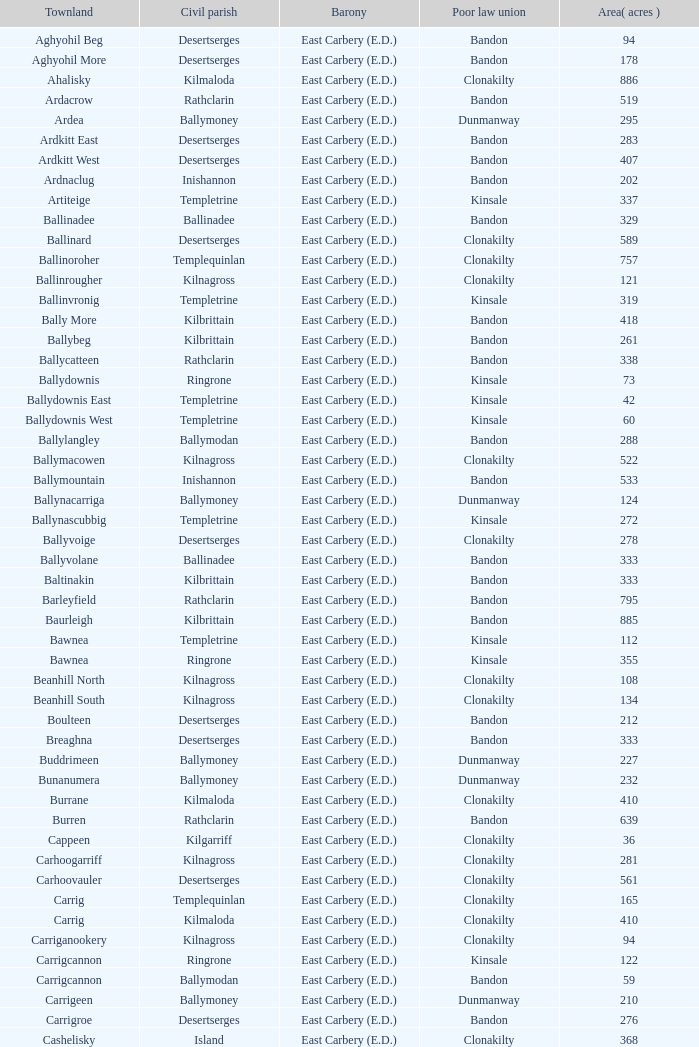Would you be able to parse every entry in this table? {'header': ['Townland', 'Civil parish', 'Barony', 'Poor law union', 'Area( acres )'], 'rows': [['Aghyohil Beg', 'Desertserges', 'East Carbery (E.D.)', 'Bandon', '94'], ['Aghyohil More', 'Desertserges', 'East Carbery (E.D.)', 'Bandon', '178'], ['Ahalisky', 'Kilmaloda', 'East Carbery (E.D.)', 'Clonakilty', '886'], ['Ardacrow', 'Rathclarin', 'East Carbery (E.D.)', 'Bandon', '519'], ['Ardea', 'Ballymoney', 'East Carbery (E.D.)', 'Dunmanway', '295'], ['Ardkitt East', 'Desertserges', 'East Carbery (E.D.)', 'Bandon', '283'], ['Ardkitt West', 'Desertserges', 'East Carbery (E.D.)', 'Bandon', '407'], ['Ardnaclug', 'Inishannon', 'East Carbery (E.D.)', 'Bandon', '202'], ['Artiteige', 'Templetrine', 'East Carbery (E.D.)', 'Kinsale', '337'], ['Ballinadee', 'Ballinadee', 'East Carbery (E.D.)', 'Bandon', '329'], ['Ballinard', 'Desertserges', 'East Carbery (E.D.)', 'Clonakilty', '589'], ['Ballinoroher', 'Templequinlan', 'East Carbery (E.D.)', 'Clonakilty', '757'], ['Ballinrougher', 'Kilnagross', 'East Carbery (E.D.)', 'Clonakilty', '121'], ['Ballinvronig', 'Templetrine', 'East Carbery (E.D.)', 'Kinsale', '319'], ['Bally More', 'Kilbrittain', 'East Carbery (E.D.)', 'Bandon', '418'], ['Ballybeg', 'Kilbrittain', 'East Carbery (E.D.)', 'Bandon', '261'], ['Ballycatteen', 'Rathclarin', 'East Carbery (E.D.)', 'Bandon', '338'], ['Ballydownis', 'Ringrone', 'East Carbery (E.D.)', 'Kinsale', '73'], ['Ballydownis East', 'Templetrine', 'East Carbery (E.D.)', 'Kinsale', '42'], ['Ballydownis West', 'Templetrine', 'East Carbery (E.D.)', 'Kinsale', '60'], ['Ballylangley', 'Ballymodan', 'East Carbery (E.D.)', 'Bandon', '288'], ['Ballymacowen', 'Kilnagross', 'East Carbery (E.D.)', 'Clonakilty', '522'], ['Ballymountain', 'Inishannon', 'East Carbery (E.D.)', 'Bandon', '533'], ['Ballynacarriga', 'Ballymoney', 'East Carbery (E.D.)', 'Dunmanway', '124'], ['Ballynascubbig', 'Templetrine', 'East Carbery (E.D.)', 'Kinsale', '272'], ['Ballyvoige', 'Desertserges', 'East Carbery (E.D.)', 'Clonakilty', '278'], ['Ballyvolane', 'Ballinadee', 'East Carbery (E.D.)', 'Bandon', '333'], ['Baltinakin', 'Kilbrittain', 'East Carbery (E.D.)', 'Bandon', '333'], ['Barleyfield', 'Rathclarin', 'East Carbery (E.D.)', 'Bandon', '795'], ['Baurleigh', 'Kilbrittain', 'East Carbery (E.D.)', 'Bandon', '885'], ['Bawnea', 'Templetrine', 'East Carbery (E.D.)', 'Kinsale', '112'], ['Bawnea', 'Ringrone', 'East Carbery (E.D.)', 'Kinsale', '355'], ['Beanhill North', 'Kilnagross', 'East Carbery (E.D.)', 'Clonakilty', '108'], ['Beanhill South', 'Kilnagross', 'East Carbery (E.D.)', 'Clonakilty', '134'], ['Boulteen', 'Desertserges', 'East Carbery (E.D.)', 'Bandon', '212'], ['Breaghna', 'Desertserges', 'East Carbery (E.D.)', 'Bandon', '333'], ['Buddrimeen', 'Ballymoney', 'East Carbery (E.D.)', 'Dunmanway', '227'], ['Bunanumera', 'Ballymoney', 'East Carbery (E.D.)', 'Dunmanway', '232'], ['Burrane', 'Kilmaloda', 'East Carbery (E.D.)', 'Clonakilty', '410'], ['Burren', 'Rathclarin', 'East Carbery (E.D.)', 'Bandon', '639'], ['Cappeen', 'Kilgarriff', 'East Carbery (E.D.)', 'Clonakilty', '36'], ['Carhoogarriff', 'Kilnagross', 'East Carbery (E.D.)', 'Clonakilty', '281'], ['Carhoovauler', 'Desertserges', 'East Carbery (E.D.)', 'Clonakilty', '561'], ['Carrig', 'Templequinlan', 'East Carbery (E.D.)', 'Clonakilty', '165'], ['Carrig', 'Kilmaloda', 'East Carbery (E.D.)', 'Clonakilty', '410'], ['Carriganookery', 'Kilnagross', 'East Carbery (E.D.)', 'Clonakilty', '94'], ['Carrigcannon', 'Ringrone', 'East Carbery (E.D.)', 'Kinsale', '122'], ['Carrigcannon', 'Ballymodan', 'East Carbery (E.D.)', 'Bandon', '59'], ['Carrigeen', 'Ballymoney', 'East Carbery (E.D.)', 'Dunmanway', '210'], ['Carrigroe', 'Desertserges', 'East Carbery (E.D.)', 'Bandon', '276'], ['Cashelisky', 'Island', 'East Carbery (E.D.)', 'Clonakilty', '368'], ['Castlederry', 'Desertserges', 'East Carbery (E.D.)', 'Clonakilty', '148'], ['Clashafree', 'Ballymodan', 'East Carbery (E.D.)', 'Bandon', '477'], ['Clashreagh', 'Templetrine', 'East Carbery (E.D.)', 'Kinsale', '132'], ['Clogagh North', 'Kilmaloda', 'East Carbery (E.D.)', 'Clonakilty', '173'], ['Clogagh South', 'Kilmaloda', 'East Carbery (E.D.)', 'Clonakilty', '282'], ['Cloghane', 'Ballinadee', 'East Carbery (E.D.)', 'Bandon', '488'], ['Clogheenavodig', 'Ballymodan', 'East Carbery (E.D.)', 'Bandon', '70'], ['Cloghmacsimon', 'Ballymodan', 'East Carbery (E.D.)', 'Bandon', '258'], ['Cloheen', 'Kilgarriff', 'East Carbery (E.D.)', 'Clonakilty', '360'], ['Cloheen', 'Island', 'East Carbery (E.D.)', 'Clonakilty', '80'], ['Clonbouig', 'Templetrine', 'East Carbery (E.D.)', 'Kinsale', '209'], ['Clonbouig', 'Ringrone', 'East Carbery (E.D.)', 'Kinsale', '219'], ['Cloncouse', 'Ballinadee', 'East Carbery (E.D.)', 'Bandon', '241'], ['Clooncalla Beg', 'Rathclarin', 'East Carbery (E.D.)', 'Bandon', '219'], ['Clooncalla More', 'Rathclarin', 'East Carbery (E.D.)', 'Bandon', '543'], ['Cloonderreen', 'Rathclarin', 'East Carbery (E.D.)', 'Bandon', '291'], ['Coolmain', 'Ringrone', 'East Carbery (E.D.)', 'Kinsale', '450'], ['Corravreeda East', 'Ballymodan', 'East Carbery (E.D.)', 'Bandon', '258'], ['Corravreeda West', 'Ballymodan', 'East Carbery (E.D.)', 'Bandon', '169'], ['Cripplehill', 'Ballymodan', 'East Carbery (E.D.)', 'Bandon', '125'], ['Cripplehill', 'Kilbrittain', 'East Carbery (E.D.)', 'Bandon', '93'], ['Crohane', 'Kilnagross', 'East Carbery (E.D.)', 'Clonakilty', '91'], ['Crohane East', 'Desertserges', 'East Carbery (E.D.)', 'Clonakilty', '108'], ['Crohane West', 'Desertserges', 'East Carbery (E.D.)', 'Clonakilty', '69'], ['Crohane (or Bandon)', 'Desertserges', 'East Carbery (E.D.)', 'Clonakilty', '204'], ['Crohane (or Bandon)', 'Kilnagross', 'East Carbery (E.D.)', 'Clonakilty', '250'], ['Currabeg', 'Ballymoney', 'East Carbery (E.D.)', 'Dunmanway', '173'], ['Curraghcrowly East', 'Ballymoney', 'East Carbery (E.D.)', 'Dunmanway', '327'], ['Curraghcrowly West', 'Ballymoney', 'East Carbery (E.D.)', 'Dunmanway', '242'], ['Curraghgrane More', 'Desert', 'East Carbery (E.D.)', 'Clonakilty', '110'], ['Currane', 'Desertserges', 'East Carbery (E.D.)', 'Clonakilty', '156'], ['Curranure', 'Inishannon', 'East Carbery (E.D.)', 'Bandon', '362'], ['Currarane', 'Templetrine', 'East Carbery (E.D.)', 'Kinsale', '100'], ['Currarane', 'Ringrone', 'East Carbery (E.D.)', 'Kinsale', '271'], ['Derrigra', 'Ballymoney', 'East Carbery (E.D.)', 'Dunmanway', '177'], ['Derrigra West', 'Ballymoney', 'East Carbery (E.D.)', 'Dunmanway', '320'], ['Derry', 'Desertserges', 'East Carbery (E.D.)', 'Clonakilty', '140'], ['Derrymeeleen', 'Desertserges', 'East Carbery (E.D.)', 'Clonakilty', '441'], ['Desert', 'Desert', 'East Carbery (E.D.)', 'Clonakilty', '339'], ['Drombofinny', 'Desertserges', 'East Carbery (E.D.)', 'Bandon', '86'], ['Dromgarriff', 'Kilmaloda', 'East Carbery (E.D.)', 'Clonakilty', '335'], ['Dromgarriff East', 'Kilnagross', 'East Carbery (E.D.)', 'Clonakilty', '385'], ['Dromgarriff West', 'Kilnagross', 'East Carbery (E.D.)', 'Clonakilty', '138'], ['Dromkeen', 'Inishannon', 'East Carbery (E.D.)', 'Bandon', '673'], ['Edencurra', 'Ballymoney', 'East Carbery (E.D.)', 'Dunmanway', '516'], ['Farran', 'Kilmaloda', 'East Carbery (E.D.)', 'Clonakilty', '502'], ['Farranagow', 'Inishannon', 'East Carbery (E.D.)', 'Bandon', '99'], ['Farrannagark', 'Rathclarin', 'East Carbery (E.D.)', 'Bandon', '290'], ['Farrannasheshery', 'Desertserges', 'East Carbery (E.D.)', 'Bandon', '304'], ['Fourcuil', 'Kilgarriff', 'East Carbery (E.D.)', 'Clonakilty', '125'], ['Fourcuil', 'Templebryan', 'East Carbery (E.D.)', 'Clonakilty', '244'], ['Garranbeg', 'Ballymodan', 'East Carbery (E.D.)', 'Bandon', '170'], ['Garraneanasig', 'Ringrone', 'East Carbery (E.D.)', 'Kinsale', '270'], ['Garraneard', 'Kilnagross', 'East Carbery (E.D.)', 'Clonakilty', '276'], ['Garranecore', 'Templebryan', 'East Carbery (E.D.)', 'Clonakilty', '144'], ['Garranecore', 'Kilgarriff', 'East Carbery (E.D.)', 'Clonakilty', '186'], ['Garranefeen', 'Rathclarin', 'East Carbery (E.D.)', 'Bandon', '478'], ['Garraneishal', 'Kilnagross', 'East Carbery (E.D.)', 'Clonakilty', '121'], ['Garranelahan', 'Desertserges', 'East Carbery (E.D.)', 'Bandon', '126'], ['Garranereagh', 'Ringrone', 'East Carbery (E.D.)', 'Kinsale', '398'], ['Garranes', 'Desertserges', 'East Carbery (E.D.)', 'Clonakilty', '416'], ['Garranure', 'Ballymoney', 'East Carbery (E.D.)', 'Dunmanway', '436'], ['Garryndruig', 'Rathclarin', 'East Carbery (E.D.)', 'Bandon', '856'], ['Glan', 'Ballymoney', 'East Carbery (E.D.)', 'Dunmanway', '194'], ['Glanavaud', 'Ringrone', 'East Carbery (E.D.)', 'Kinsale', '98'], ['Glanavirane', 'Templetrine', 'East Carbery (E.D.)', 'Kinsale', '107'], ['Glanavirane', 'Ringrone', 'East Carbery (E.D.)', 'Kinsale', '91'], ['Glanduff', 'Rathclarin', 'East Carbery (E.D.)', 'Bandon', '464'], ['Grillagh', 'Kilnagross', 'East Carbery (E.D.)', 'Clonakilty', '136'], ['Grillagh', 'Ballymoney', 'East Carbery (E.D.)', 'Dunmanway', '316'], ['Hacketstown', 'Templetrine', 'East Carbery (E.D.)', 'Kinsale', '182'], ['Inchafune', 'Ballymoney', 'East Carbery (E.D.)', 'Dunmanway', '871'], ['Inchydoney Island', 'Island', 'East Carbery (E.D.)', 'Clonakilty', '474'], ['Kilbeloge', 'Desertserges', 'East Carbery (E.D.)', 'Clonakilty', '216'], ['Kilbree', 'Island', 'East Carbery (E.D.)', 'Clonakilty', '284'], ['Kilbrittain', 'Kilbrittain', 'East Carbery (E.D.)', 'Bandon', '483'], ['Kilcaskan', 'Ballymoney', 'East Carbery (E.D.)', 'Dunmanway', '221'], ['Kildarra', 'Ballinadee', 'East Carbery (E.D.)', 'Bandon', '463'], ['Kilgarriff', 'Kilgarriff', 'East Carbery (E.D.)', 'Clonakilty', '835'], ['Kilgobbin', 'Ballinadee', 'East Carbery (E.D.)', 'Bandon', '1263'], ['Kill North', 'Desertserges', 'East Carbery (E.D.)', 'Clonakilty', '136'], ['Kill South', 'Desertserges', 'East Carbery (E.D.)', 'Clonakilty', '139'], ['Killanamaul', 'Kilbrittain', 'East Carbery (E.D.)', 'Bandon', '220'], ['Killaneetig', 'Ballinadee', 'East Carbery (E.D.)', 'Bandon', '342'], ['Killavarrig', 'Timoleague', 'East Carbery (E.D.)', 'Clonakilty', '708'], ['Killeen', 'Desertserges', 'East Carbery (E.D.)', 'Clonakilty', '309'], ['Killeens', 'Templetrine', 'East Carbery (E.D.)', 'Kinsale', '132'], ['Kilmacsimon', 'Ballinadee', 'East Carbery (E.D.)', 'Bandon', '219'], ['Kilmaloda', 'Kilmaloda', 'East Carbery (E.D.)', 'Clonakilty', '634'], ['Kilmoylerane North', 'Desertserges', 'East Carbery (E.D.)', 'Clonakilty', '306'], ['Kilmoylerane South', 'Desertserges', 'East Carbery (E.D.)', 'Clonakilty', '324'], ['Kilnameela', 'Desertserges', 'East Carbery (E.D.)', 'Bandon', '397'], ['Kilrush', 'Desertserges', 'East Carbery (E.D.)', 'Bandon', '189'], ['Kilshinahan', 'Kilbrittain', 'East Carbery (E.D.)', 'Bandon', '528'], ['Kilvinane', 'Ballymoney', 'East Carbery (E.D.)', 'Dunmanway', '199'], ['Kilvurra', 'Ballymoney', 'East Carbery (E.D.)', 'Dunmanway', '356'], ['Knockacullen', 'Desertserges', 'East Carbery (E.D.)', 'Clonakilty', '381'], ['Knockaneady', 'Ballymoney', 'East Carbery (E.D.)', 'Dunmanway', '393'], ['Knockaneroe', 'Templetrine', 'East Carbery (E.D.)', 'Kinsale', '127'], ['Knockanreagh', 'Ballymodan', 'East Carbery (E.D.)', 'Bandon', '139'], ['Knockbrown', 'Kilbrittain', 'East Carbery (E.D.)', 'Bandon', '312'], ['Knockbrown', 'Kilmaloda', 'East Carbery (E.D.)', 'Bandon', '510'], ['Knockeenbwee Lower', 'Dromdaleague', 'East Carbery (E.D.)', 'Skibbereen', '213'], ['Knockeenbwee Upper', 'Dromdaleague', 'East Carbery (E.D.)', 'Skibbereen', '229'], ['Knockeencon', 'Tullagh', 'East Carbery (E.D.)', 'Skibbereen', '108'], ['Knockmacool', 'Desertserges', 'East Carbery (E.D.)', 'Bandon', '241'], ['Knocknacurra', 'Ballinadee', 'East Carbery (E.D.)', 'Bandon', '422'], ['Knocknagappul', 'Ballinadee', 'East Carbery (E.D.)', 'Bandon', '507'], ['Knocknanuss', 'Desertserges', 'East Carbery (E.D.)', 'Clonakilty', '394'], ['Knocknastooka', 'Desertserges', 'East Carbery (E.D.)', 'Bandon', '118'], ['Knockroe', 'Inishannon', 'East Carbery (E.D.)', 'Bandon', '601'], ['Knocks', 'Desertserges', 'East Carbery (E.D.)', 'Clonakilty', '540'], ['Knockskagh', 'Kilgarriff', 'East Carbery (E.D.)', 'Clonakilty', '489'], ['Knoppoge', 'Kilbrittain', 'East Carbery (E.D.)', 'Bandon', '567'], ['Lackanalooha', 'Kilnagross', 'East Carbery (E.D.)', 'Clonakilty', '209'], ['Lackenagobidane', 'Island', 'East Carbery (E.D.)', 'Clonakilty', '48'], ['Lisbehegh', 'Desertserges', 'East Carbery (E.D.)', 'Clonakilty', '255'], ['Lisheen', 'Templetrine', 'East Carbery (E.D.)', 'Kinsale', '44'], ['Lisheenaleen', 'Rathclarin', 'East Carbery (E.D.)', 'Bandon', '267'], ['Lisnacunna', 'Desertserges', 'East Carbery (E.D.)', 'Bandon', '529'], ['Lisroe', 'Kilgarriff', 'East Carbery (E.D.)', 'Clonakilty', '91'], ['Lissaphooca', 'Ballymodan', 'East Carbery (E.D.)', 'Bandon', '513'], ['Lisselane', 'Kilnagross', 'East Carbery (E.D.)', 'Clonakilty', '429'], ['Madame', 'Kilmaloda', 'East Carbery (E.D.)', 'Clonakilty', '273'], ['Madame', 'Kilnagross', 'East Carbery (E.D.)', 'Clonakilty', '41'], ['Maulbrack East', 'Desertserges', 'East Carbery (E.D.)', 'Bandon', '100'], ['Maulbrack West', 'Desertserges', 'East Carbery (E.D.)', 'Bandon', '242'], ['Maulmane', 'Kilbrittain', 'East Carbery (E.D.)', 'Bandon', '219'], ['Maulnageragh', 'Kilnagross', 'East Carbery (E.D.)', 'Clonakilty', '135'], ['Maulnarouga North', 'Desertserges', 'East Carbery (E.D.)', 'Bandon', '81'], ['Maulnarouga South', 'Desertserges', 'East Carbery (E.D.)', 'Bandon', '374'], ['Maulnaskehy', 'Kilgarriff', 'East Carbery (E.D.)', 'Clonakilty', '14'], ['Maulrour', 'Desertserges', 'East Carbery (E.D.)', 'Clonakilty', '244'], ['Maulrour', 'Kilmaloda', 'East Carbery (E.D.)', 'Clonakilty', '340'], ['Maulskinlahane', 'Kilbrittain', 'East Carbery (E.D.)', 'Bandon', '245'], ['Miles', 'Kilgarriff', 'East Carbery (E.D.)', 'Clonakilty', '268'], ['Moanarone', 'Ballymodan', 'East Carbery (E.D.)', 'Bandon', '235'], ['Monteen', 'Kilmaloda', 'East Carbery (E.D.)', 'Clonakilty', '589'], ['Phale Lower', 'Ballymoney', 'East Carbery (E.D.)', 'Dunmanway', '287'], ['Phale Upper', 'Ballymoney', 'East Carbery (E.D.)', 'Dunmanway', '234'], ['Ratharoon East', 'Ballinadee', 'East Carbery (E.D.)', 'Bandon', '810'], ['Ratharoon West', 'Ballinadee', 'East Carbery (E.D.)', 'Bandon', '383'], ['Rathdrought', 'Ballinadee', 'East Carbery (E.D.)', 'Bandon', '1242'], ['Reengarrigeen', 'Kilmaloda', 'East Carbery (E.D.)', 'Clonakilty', '560'], ['Reenroe', 'Kilgarriff', 'East Carbery (E.D.)', 'Clonakilty', '123'], ['Rochestown', 'Templetrine', 'East Carbery (E.D.)', 'Kinsale', '104'], ['Rockfort', 'Brinny', 'East Carbery (E.D.)', 'Bandon', '308'], ['Rockhouse', 'Ballinadee', 'East Carbery (E.D.)', 'Bandon', '82'], ['Scartagh', 'Kilgarriff', 'East Carbery (E.D.)', 'Clonakilty', '186'], ['Shanakill', 'Rathclarin', 'East Carbery (E.D.)', 'Bandon', '197'], ['Shanaway East', 'Ballymoney', 'East Carbery (E.D.)', 'Dunmanway', '386'], ['Shanaway Middle', 'Ballymoney', 'East Carbery (E.D.)', 'Dunmanway', '296'], ['Shanaway West', 'Ballymoney', 'East Carbery (E.D.)', 'Dunmanway', '266'], ['Skeaf', 'Kilmaloda', 'East Carbery (E.D.)', 'Clonakilty', '452'], ['Skeaf East', 'Kilmaloda', 'East Carbery (E.D.)', 'Clonakilty', '371'], ['Skeaf West', 'Kilmaloda', 'East Carbery (E.D.)', 'Clonakilty', '477'], ['Skevanish', 'Inishannon', 'East Carbery (E.D.)', 'Bandon', '359'], ['Steilaneigh', 'Templetrine', 'East Carbery (E.D.)', 'Kinsale', '42'], ['Tawnies Lower', 'Kilgarriff', 'East Carbery (E.D.)', 'Clonakilty', '238'], ['Tawnies Upper', 'Kilgarriff', 'East Carbery (E.D.)', 'Clonakilty', '321'], ['Templebryan North', 'Templebryan', 'East Carbery (E.D.)', 'Clonakilty', '436'], ['Templebryan South', 'Templebryan', 'East Carbery (E.D.)', 'Clonakilty', '363'], ['Tullig', 'Kilmaloda', 'East Carbery (E.D.)', 'Clonakilty', '135'], ['Tullyland', 'Ballymodan', 'East Carbery (E.D.)', 'Bandon', '348'], ['Tullyland', 'Ballinadee', 'East Carbery (E.D.)', 'Bandon', '506'], ['Tullymurrihy', 'Desertserges', 'East Carbery (E.D.)', 'Bandon', '665'], ['Youghals', 'Island', 'East Carbery (E.D.)', 'Clonakilty', '109']]} What is the poor law union of the Kilmaloda townland? Clonakilty. 